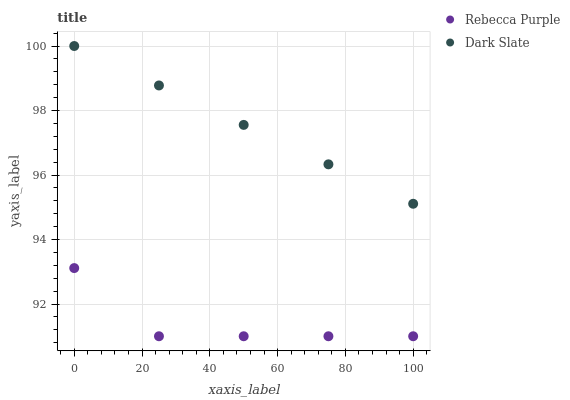Does Rebecca Purple have the minimum area under the curve?
Answer yes or no. Yes. Does Dark Slate have the maximum area under the curve?
Answer yes or no. Yes. Does Rebecca Purple have the maximum area under the curve?
Answer yes or no. No. Is Dark Slate the smoothest?
Answer yes or no. Yes. Is Rebecca Purple the roughest?
Answer yes or no. Yes. Is Rebecca Purple the smoothest?
Answer yes or no. No. Does Rebecca Purple have the lowest value?
Answer yes or no. Yes. Does Dark Slate have the highest value?
Answer yes or no. Yes. Does Rebecca Purple have the highest value?
Answer yes or no. No. Is Rebecca Purple less than Dark Slate?
Answer yes or no. Yes. Is Dark Slate greater than Rebecca Purple?
Answer yes or no. Yes. Does Rebecca Purple intersect Dark Slate?
Answer yes or no. No. 